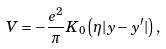Convert formula to latex. <formula><loc_0><loc_0><loc_500><loc_500>V = - \frac { e ^ { 2 } } { \pi } K _ { 0 } \left ( \eta | y - y ^ { \prime } | \right ) ,</formula> 